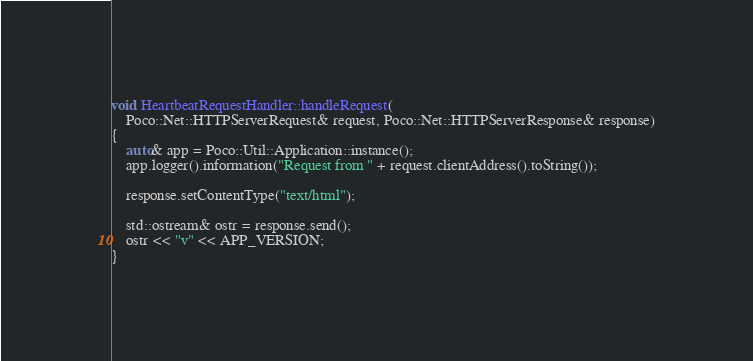<code> <loc_0><loc_0><loc_500><loc_500><_C++_>void HeartbeatRequestHandler::handleRequest(
    Poco::Net::HTTPServerRequest& request, Poco::Net::HTTPServerResponse& response)
{
    auto& app = Poco::Util::Application::instance();
    app.logger().information("Request from " + request.clientAddress().toString());

    response.setContentType("text/html");

    std::ostream& ostr = response.send();
    ostr << "v" << APP_VERSION;
}
</code> 